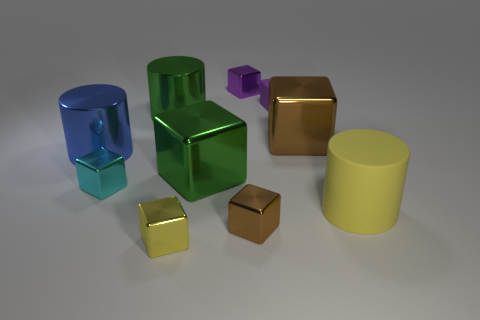What size is the shiny cube that is the same color as the small rubber thing?
Your answer should be compact. Small. There is a large cylinder to the right of the small yellow thing that is to the left of the big green metallic cube; what is it made of?
Ensure brevity in your answer.  Rubber. Do the yellow cylinder and the cube on the left side of the small yellow shiny block have the same material?
Provide a short and direct response. No. What is the block that is to the right of the tiny yellow shiny thing and in front of the tiny cyan shiny thing made of?
Your response must be concise. Metal. What color is the metallic thing right of the brown metallic cube that is in front of the matte cylinder?
Keep it short and to the point. Brown. There is a large yellow cylinder in front of the purple shiny cube; what material is it?
Ensure brevity in your answer.  Rubber. Are there fewer small yellow metal objects than large yellow balls?
Ensure brevity in your answer.  No. Is the shape of the small cyan thing the same as the small brown shiny object in front of the large brown cube?
Keep it short and to the point. Yes. The big object that is both on the right side of the matte block and on the left side of the big yellow rubber cylinder has what shape?
Make the answer very short. Cube. Are there the same number of yellow metallic objects that are behind the tiny cyan shiny block and tiny brown blocks in front of the green cylinder?
Offer a very short reply. No. 